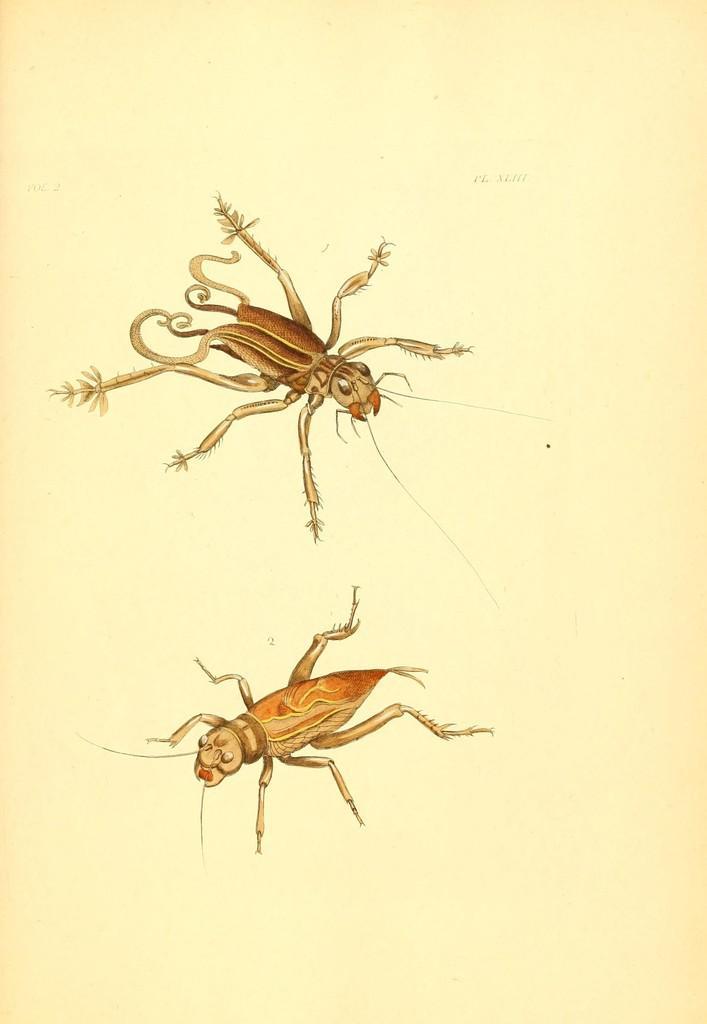Please provide a concise description of this image. In this image, I can see the drawing of an insect in the paper. 